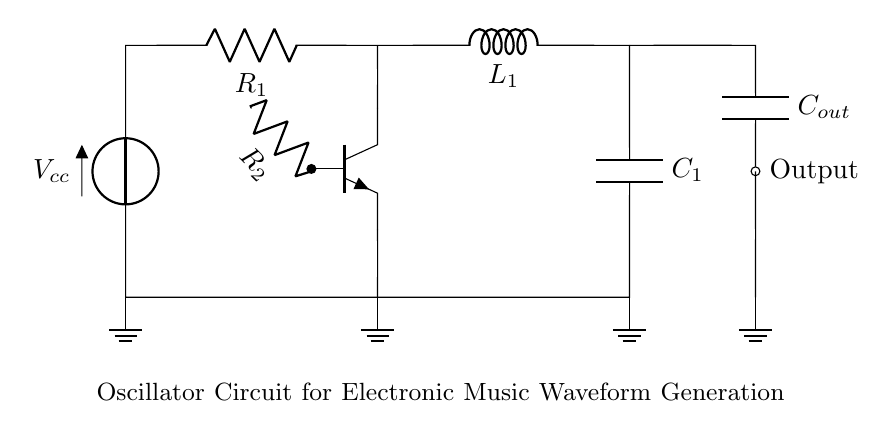What is the voltage source in this circuit? The voltage source is represented by the symbol Vcc in the circuit diagram, indicating it provides the required voltage for the operation of the oscillator circuit.
Answer: Vcc What components are used in this oscillator circuit? The circuit diagram contains a voltage source, a resistor, an inductor, a capacitor, and a transistor (specifically an NPN transistor). By identifying each component based on their symbols, we see these key elements.
Answer: Resistor, Inductor, Capacitor, Transistor How many outputs does this circuit have? The circuit has one output, which is indicated by the node labeled as "Output" connected to the capacitor and shown at the right side of the diagram.
Answer: One What type of circuit is this? The circuit is an oscillator circuit, as indicated by its primary function to generate waveforms, which is evident from the arrangement of components responsible for tuning frequency.
Answer: Oscillator What role does the inductor play in this circuit? The inductor in this circuit is crucial for storing energy in a magnetic field when current passes through it, which works with the capacitor to determine the oscillation frequency of the circuit.
Answer: Energy storage How does the capacitor affect the frequency of the oscillator? The capacitor determines the frequency of oscillation in conjunction with the inductor; their values (capacitance and inductance) are inversely linked to the oscillation frequency, following the formula related to resonant frequency.
Answer: Frequency determinant What is the function of the resistor R2 in relation to the transistor? Resistor R2 serves as a base resistor for the transistor, controlling the base current, and hence the transistor's operation, influencing the oscillation behavior of the circuit.
Answer: Base current control 